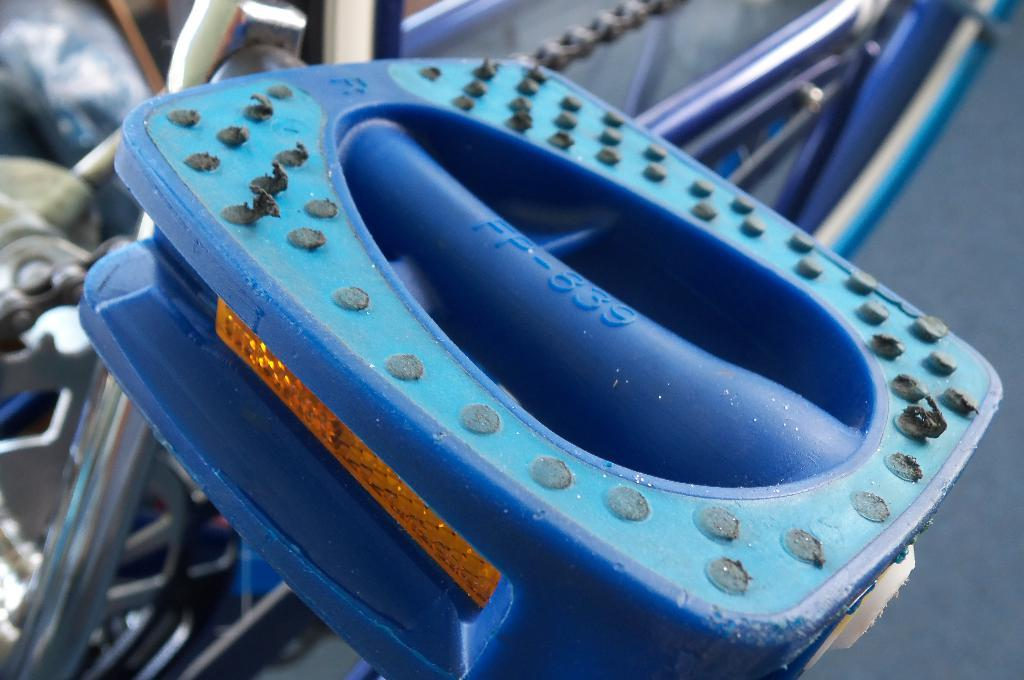What is the color of the object that is visible in the image? The object is blue. What is located behind the blue object in the image? There is a chain and rods visible behind the blue object. How many screws can be seen attached to the blue object in the image? There are no screws visible attached to the blue object in the image. What type of mass is present in the image? There is no mass present in the image; the term "mass" is not applicable to the objects shown. 